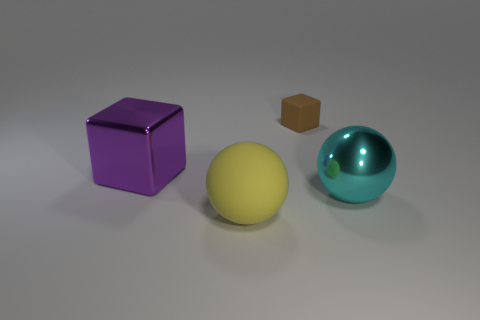How many green objects are either matte blocks or rubber balls?
Provide a succinct answer. 0. What is the big sphere that is left of the brown rubber object behind the big cyan metal thing made of?
Your response must be concise. Rubber. Do the tiny brown matte object and the big purple thing have the same shape?
Your response must be concise. Yes. What color is the other matte object that is the same size as the purple object?
Give a very brief answer. Yellow. Is there a big matte ball of the same color as the big cube?
Keep it short and to the point. No. Are any tiny green rubber objects visible?
Make the answer very short. No. Are the sphere behind the rubber ball and the purple thing made of the same material?
Ensure brevity in your answer.  Yes. What number of yellow rubber objects are the same size as the purple thing?
Give a very brief answer. 1. Are there the same number of cyan shiny things that are on the right side of the big cyan shiny thing and big blue things?
Your answer should be compact. Yes. How many objects are on the right side of the large yellow matte sphere and left of the brown rubber block?
Make the answer very short. 0. 